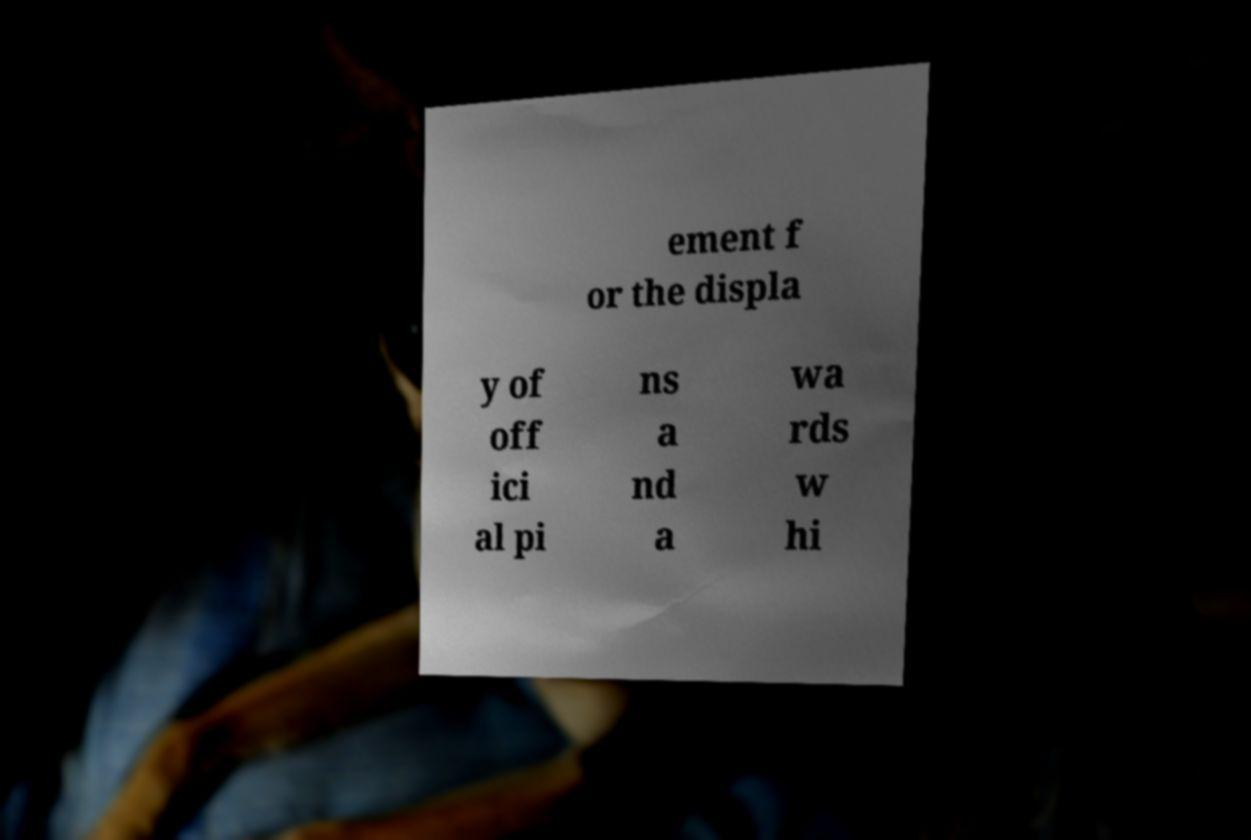Can you read and provide the text displayed in the image?This photo seems to have some interesting text. Can you extract and type it out for me? ement f or the displa y of off ici al pi ns a nd a wa rds w hi 